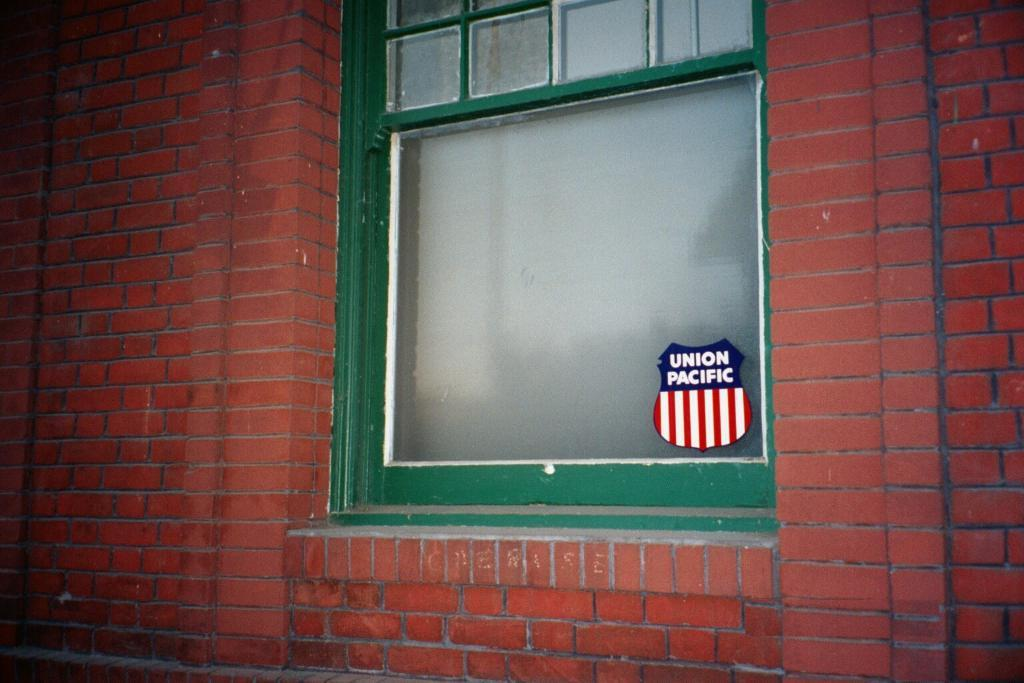<image>
Give a short and clear explanation of the subsequent image. A Union Pacific sticker is attached to a glass window 